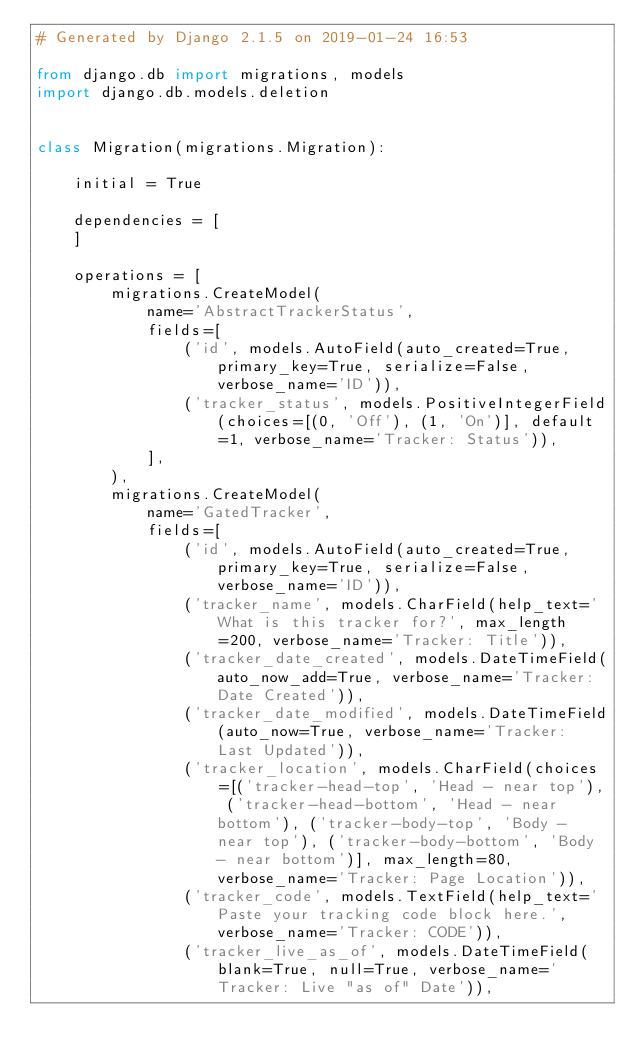Convert code to text. <code><loc_0><loc_0><loc_500><loc_500><_Python_># Generated by Django 2.1.5 on 2019-01-24 16:53

from django.db import migrations, models
import django.db.models.deletion


class Migration(migrations.Migration):

    initial = True

    dependencies = [
    ]

    operations = [
        migrations.CreateModel(
            name='AbstractTrackerStatus',
            fields=[
                ('id', models.AutoField(auto_created=True, primary_key=True, serialize=False, verbose_name='ID')),
                ('tracker_status', models.PositiveIntegerField(choices=[(0, 'Off'), (1, 'On')], default=1, verbose_name='Tracker: Status')),
            ],
        ),
        migrations.CreateModel(
            name='GatedTracker',
            fields=[
                ('id', models.AutoField(auto_created=True, primary_key=True, serialize=False, verbose_name='ID')),
                ('tracker_name', models.CharField(help_text='What is this tracker for?', max_length=200, verbose_name='Tracker: Title')),
                ('tracker_date_created', models.DateTimeField(auto_now_add=True, verbose_name='Tracker: Date Created')),
                ('tracker_date_modified', models.DateTimeField(auto_now=True, verbose_name='Tracker: Last Updated')),
                ('tracker_location', models.CharField(choices=[('tracker-head-top', 'Head - near top'), ('tracker-head-bottom', 'Head - near bottom'), ('tracker-body-top', 'Body - near top'), ('tracker-body-bottom', 'Body - near bottom')], max_length=80, verbose_name='Tracker: Page Location')),
                ('tracker_code', models.TextField(help_text='Paste your tracking code block here.', verbose_name='Tracker: CODE')),
                ('tracker_live_as_of', models.DateTimeField(blank=True, null=True, verbose_name='Tracker: Live "as of" Date')),</code> 